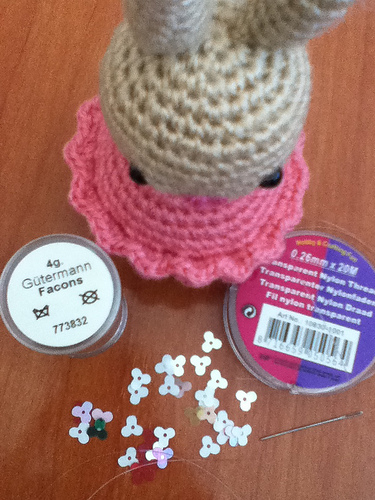<image>
Is the yarn on the lid? No. The yarn is not positioned on the lid. They may be near each other, but the yarn is not supported by or resting on top of the lid. 